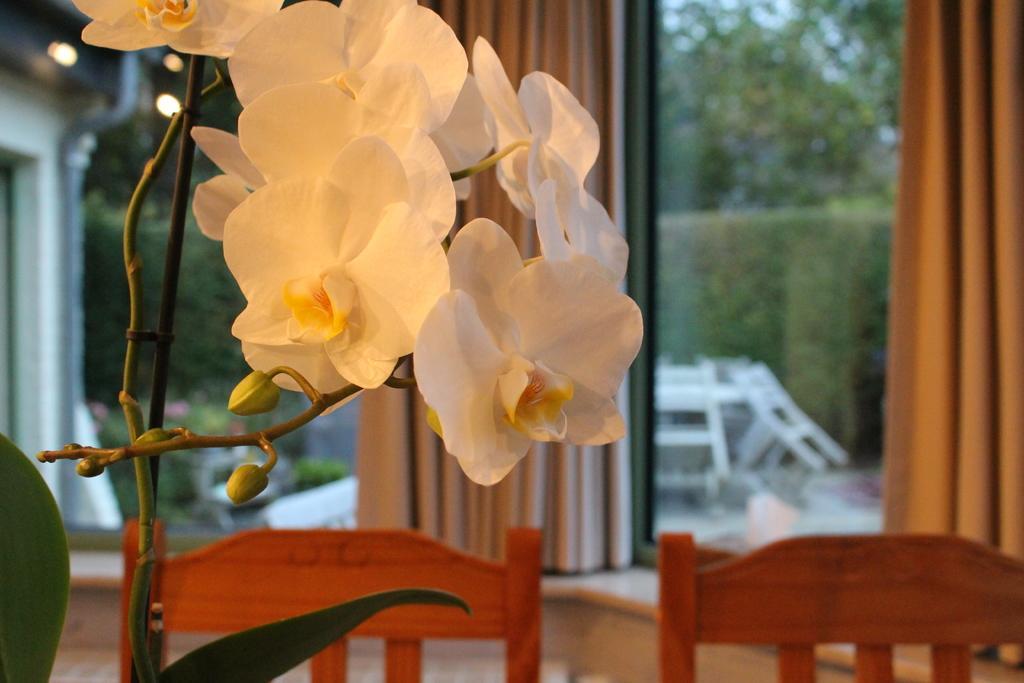How would you summarize this image in a sentence or two? This picture shows a plant with flowers and we see few chairs as and me couple of curtains and we see few trees from the window 